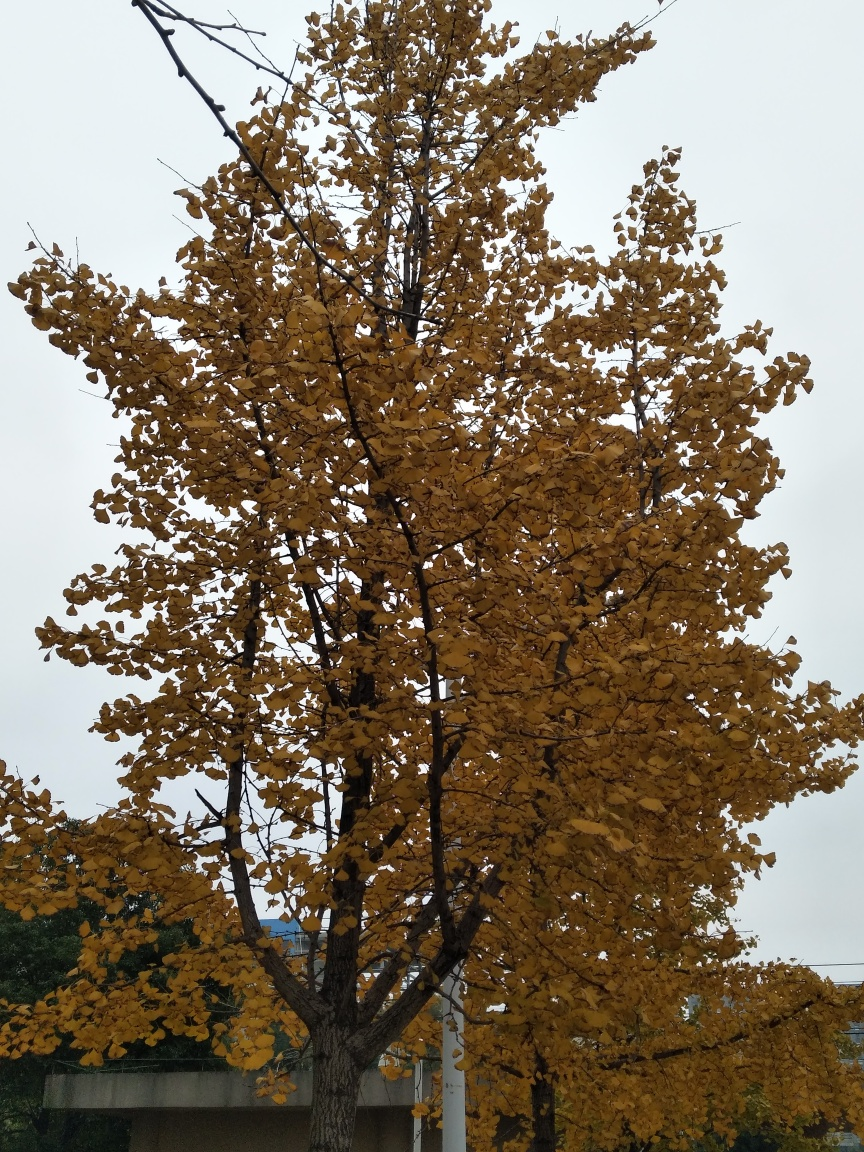What can you infer about the climate and wellbeing of the tree? The tree's dense foliage and widespread branches indicate good health and robust growth, typical of a tree well-suited to its climate. The seasonal shedding of leaves implies a temperate region with distinct seasons, where trees undergo such changes to adapt and prepare for the winter. The leaves' consistent coloration suggests a lack of disease or stress. 